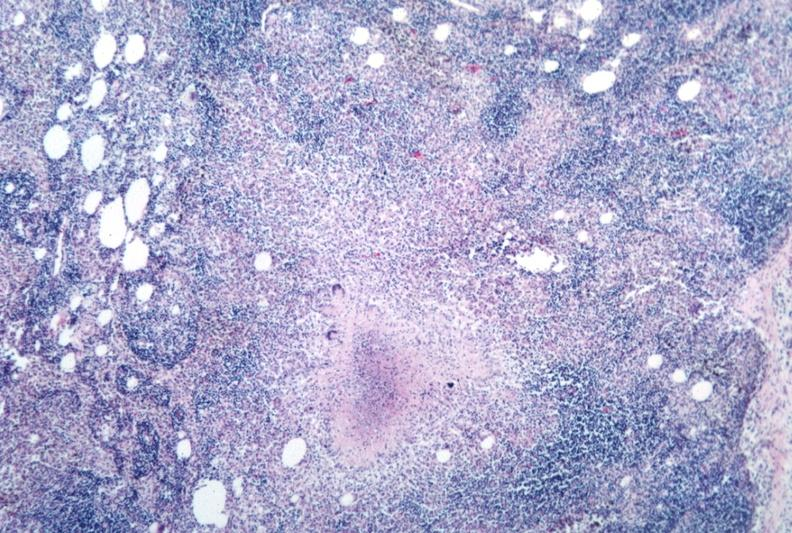s gross photo of tumor in this file present?
Answer the question using a single word or phrase. No 